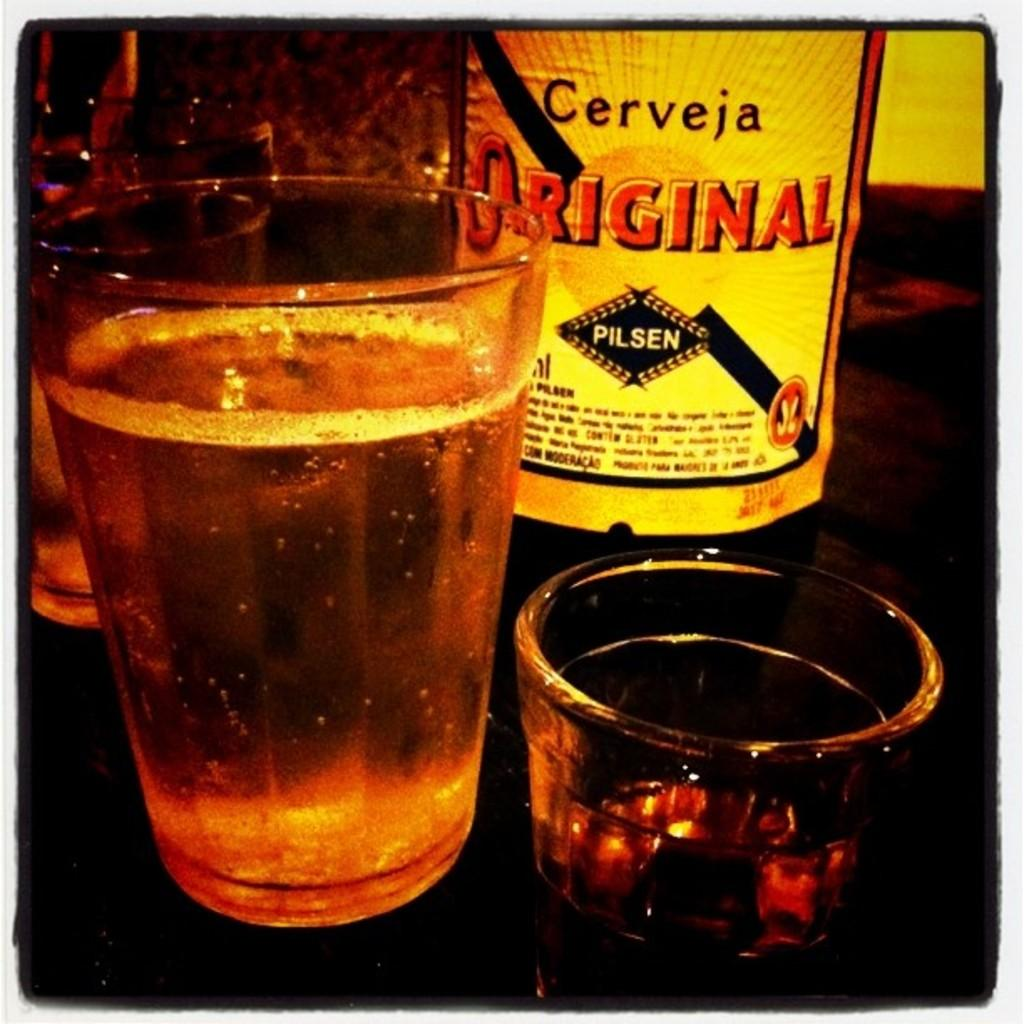<image>
Summarize the visual content of the image. A bottle of Cerveja Original sitting next to two glasses 